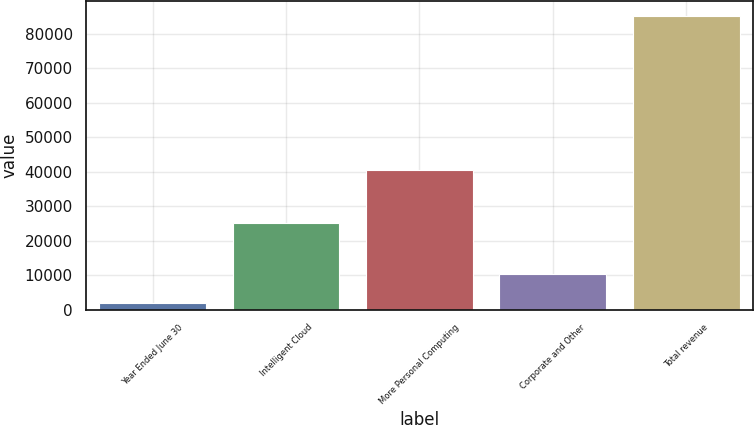<chart> <loc_0><loc_0><loc_500><loc_500><bar_chart><fcel>Year Ended June 30<fcel>Intelligent Cloud<fcel>More Personal Computing<fcel>Corporate and Other<fcel>Total revenue<nl><fcel>2016<fcel>25042<fcel>40460<fcel>10346.4<fcel>85320<nl></chart> 